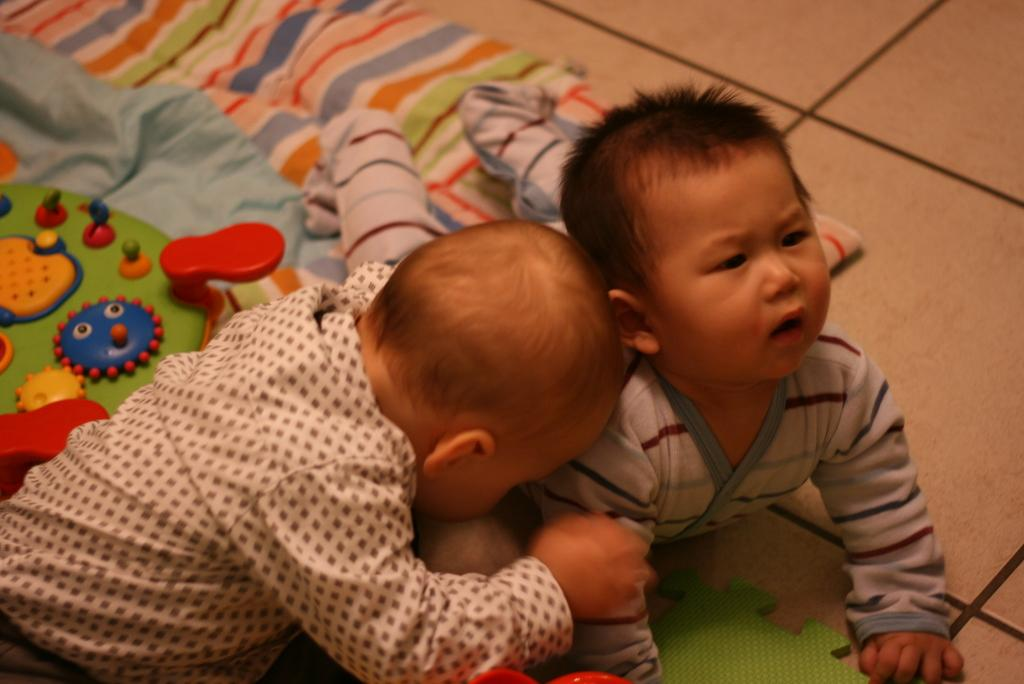What is the baby in the image wearing? The baby is wearing a shirt. How is the baby positioned in the image? The baby is resting its head on the shoulder of another baby. What is the position of the other baby in the image? The other baby is lying on the floor. What is present on the floor in the image? There is a cloth on the floor. What type of string is being used to measure the wealth of the babies in the image? There is no string or measurement of wealth present in the image; it simply shows two babies in different positions. 